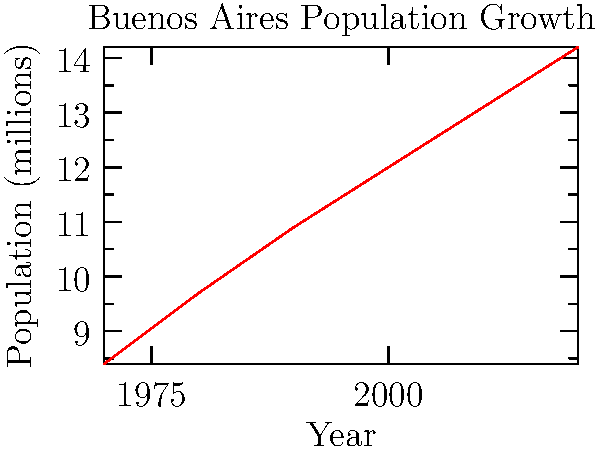Based on the line graph showing the population growth of Buenos Aires over the past 50 years, what was the approximate increase in population between 1970 and 2020? To find the population increase between 1970 and 2020:

1. Identify the population in 1970: 8.4 million
2. Identify the population in 2020: 14.2 million
3. Calculate the difference:
   $14.2 - 8.4 = 5.8$ million

The population increased by approximately 5.8 million people over the 50-year period.

To verify:
- The graph shows a steady upward trend.
- The increase is slightly more than half of the 1970 population.
- The line spans about 2/3 of the vertical axis, which represents about 6 million.

Therefore, an increase of 5.8 million is consistent with the graph.
Answer: 5.8 million 